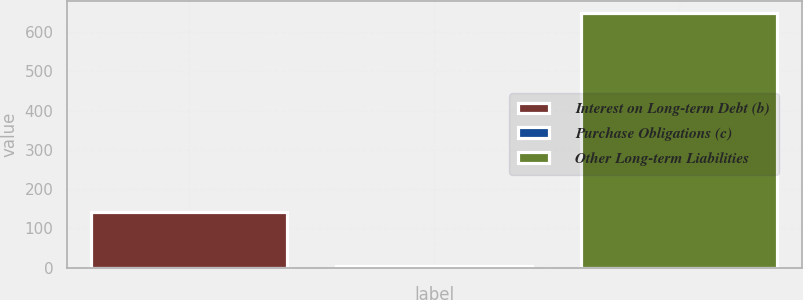Convert chart to OTSL. <chart><loc_0><loc_0><loc_500><loc_500><bar_chart><fcel>Interest on Long-term Debt (b)<fcel>Purchase Obligations (c)<fcel>Other Long-term Liabilities<nl><fcel>143<fcel>5<fcel>648<nl></chart> 